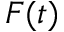<formula> <loc_0><loc_0><loc_500><loc_500>F ( t )</formula> 